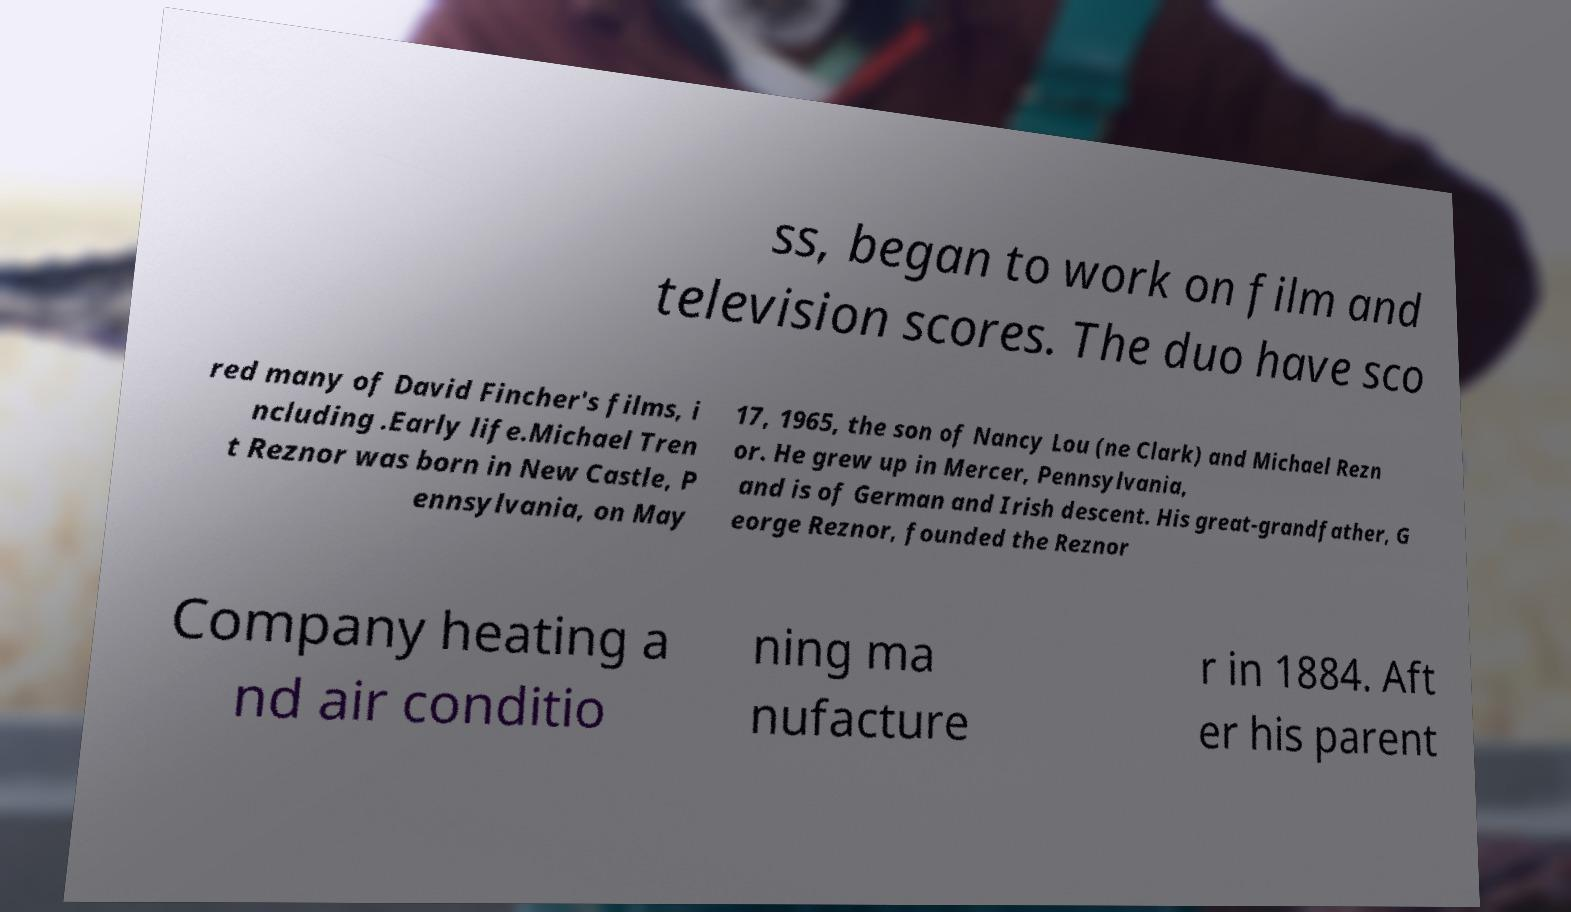Could you assist in decoding the text presented in this image and type it out clearly? ss, began to work on film and television scores. The duo have sco red many of David Fincher's films, i ncluding .Early life.Michael Tren t Reznor was born in New Castle, P ennsylvania, on May 17, 1965, the son of Nancy Lou (ne Clark) and Michael Rezn or. He grew up in Mercer, Pennsylvania, and is of German and Irish descent. His great-grandfather, G eorge Reznor, founded the Reznor Company heating a nd air conditio ning ma nufacture r in 1884. Aft er his parent 